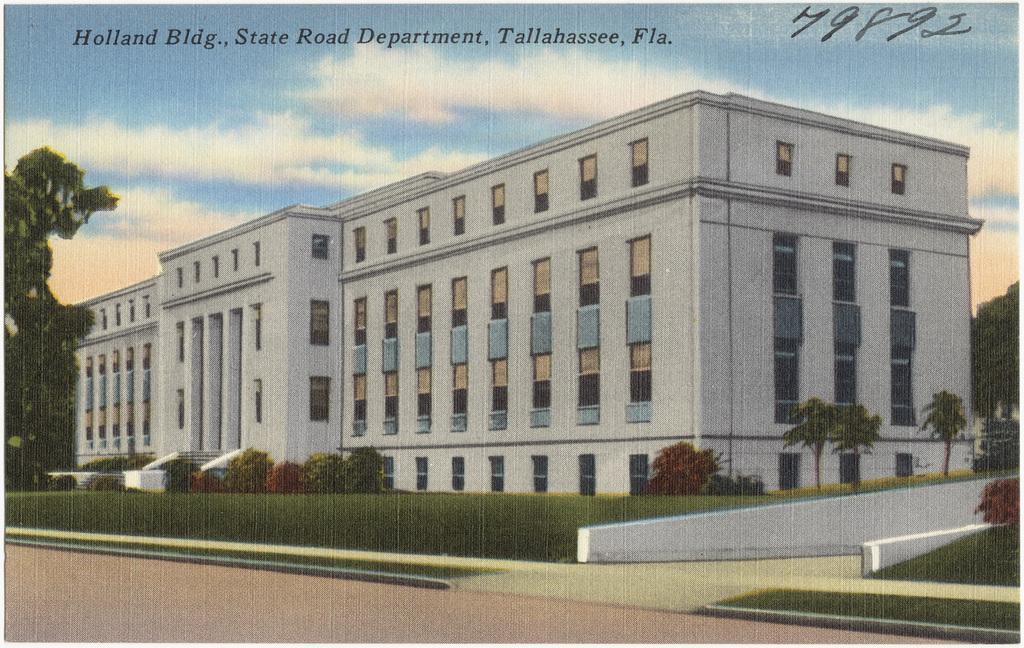Describe this image in one or two sentences. In this picture we can see the painting. In the foreground we can see the plants, trees and green grass. In the center there is a building and the trees. In the background there is a sky with some clouds and we can see the text on the image. 